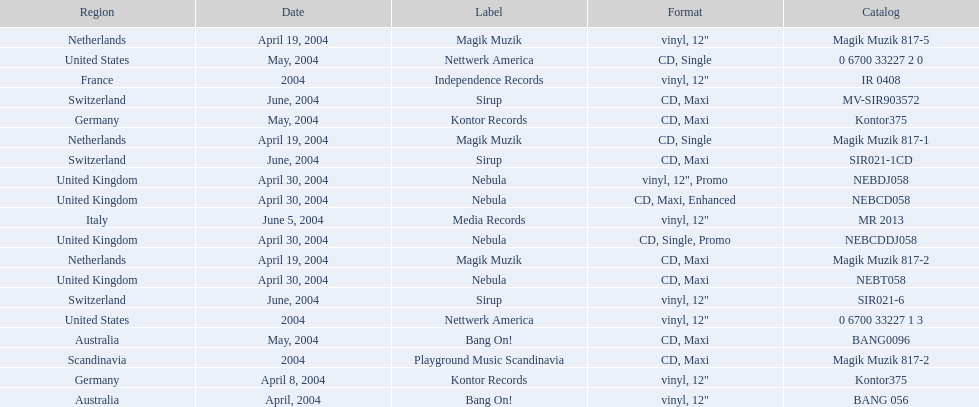What label was used by the netherlands in love comes again? Magik Muzik. What label was used in germany? Kontor Records. What label was used in france? Independence Records. 